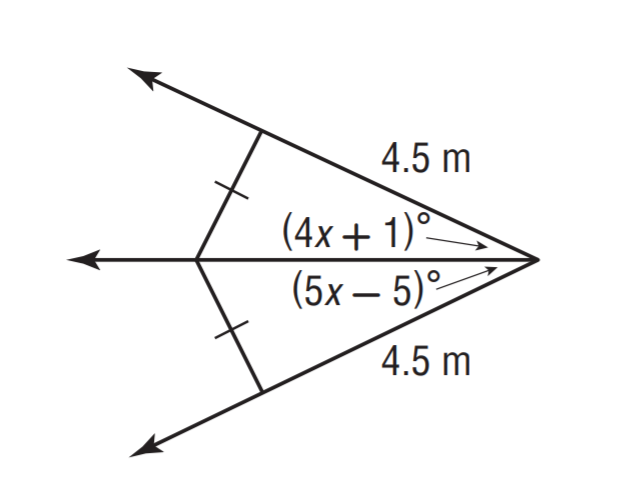Question: Solve for x.
Choices:
A. 3
B. 4
C. 5
D. 6
Answer with the letter. Answer: D 